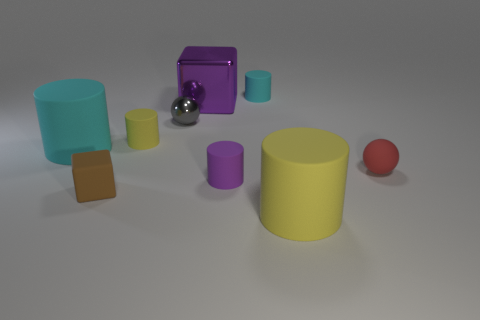What is the color of the cylinder to the right of the cyan thing behind the small yellow matte cylinder?
Ensure brevity in your answer.  Yellow. Is the size of the matte ball the same as the purple cylinder?
Your answer should be compact. Yes. There is a large thing that is the same shape as the small brown matte object; what is it made of?
Your answer should be very brief. Metal. How many balls have the same size as the purple cylinder?
Your response must be concise. 2. What is the color of the cube that is made of the same material as the small cyan thing?
Keep it short and to the point. Brown. Are there fewer small gray metal balls than cyan cylinders?
Keep it short and to the point. Yes. What number of cyan things are cylinders or spheres?
Give a very brief answer. 2. What number of objects are to the right of the tiny brown thing and in front of the purple rubber thing?
Give a very brief answer. 1. Is the material of the purple cube the same as the tiny block?
Offer a very short reply. No. There is a yellow rubber object that is the same size as the red sphere; what is its shape?
Your response must be concise. Cylinder. 